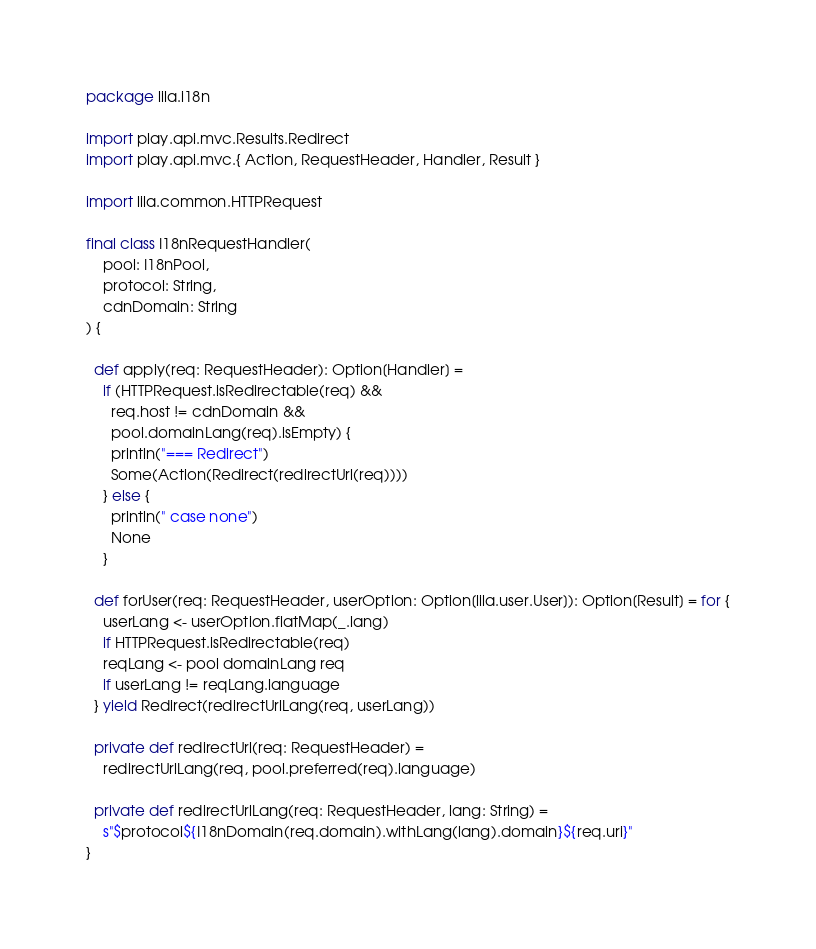Convert code to text. <code><loc_0><loc_0><loc_500><loc_500><_Scala_>package lila.i18n

import play.api.mvc.Results.Redirect
import play.api.mvc.{ Action, RequestHeader, Handler, Result }

import lila.common.HTTPRequest

final class I18nRequestHandler(
    pool: I18nPool,
    protocol: String,
    cdnDomain: String
) {

  def apply(req: RequestHeader): Option[Handler] =
    if (HTTPRequest.isRedirectable(req) &&
      req.host != cdnDomain &&
      pool.domainLang(req).isEmpty) {
      println("=== Redirect")
      Some(Action(Redirect(redirectUrl(req))))
    } else {
      println(" case none")
      None
    }

  def forUser(req: RequestHeader, userOption: Option[lila.user.User]): Option[Result] = for {
    userLang <- userOption.flatMap(_.lang)
    if HTTPRequest.isRedirectable(req)
    reqLang <- pool domainLang req
    if userLang != reqLang.language
  } yield Redirect(redirectUrlLang(req, userLang))

  private def redirectUrl(req: RequestHeader) =
    redirectUrlLang(req, pool.preferred(req).language)

  private def redirectUrlLang(req: RequestHeader, lang: String) =
    s"$protocol${I18nDomain(req.domain).withLang(lang).domain}${req.uri}"
}
</code> 